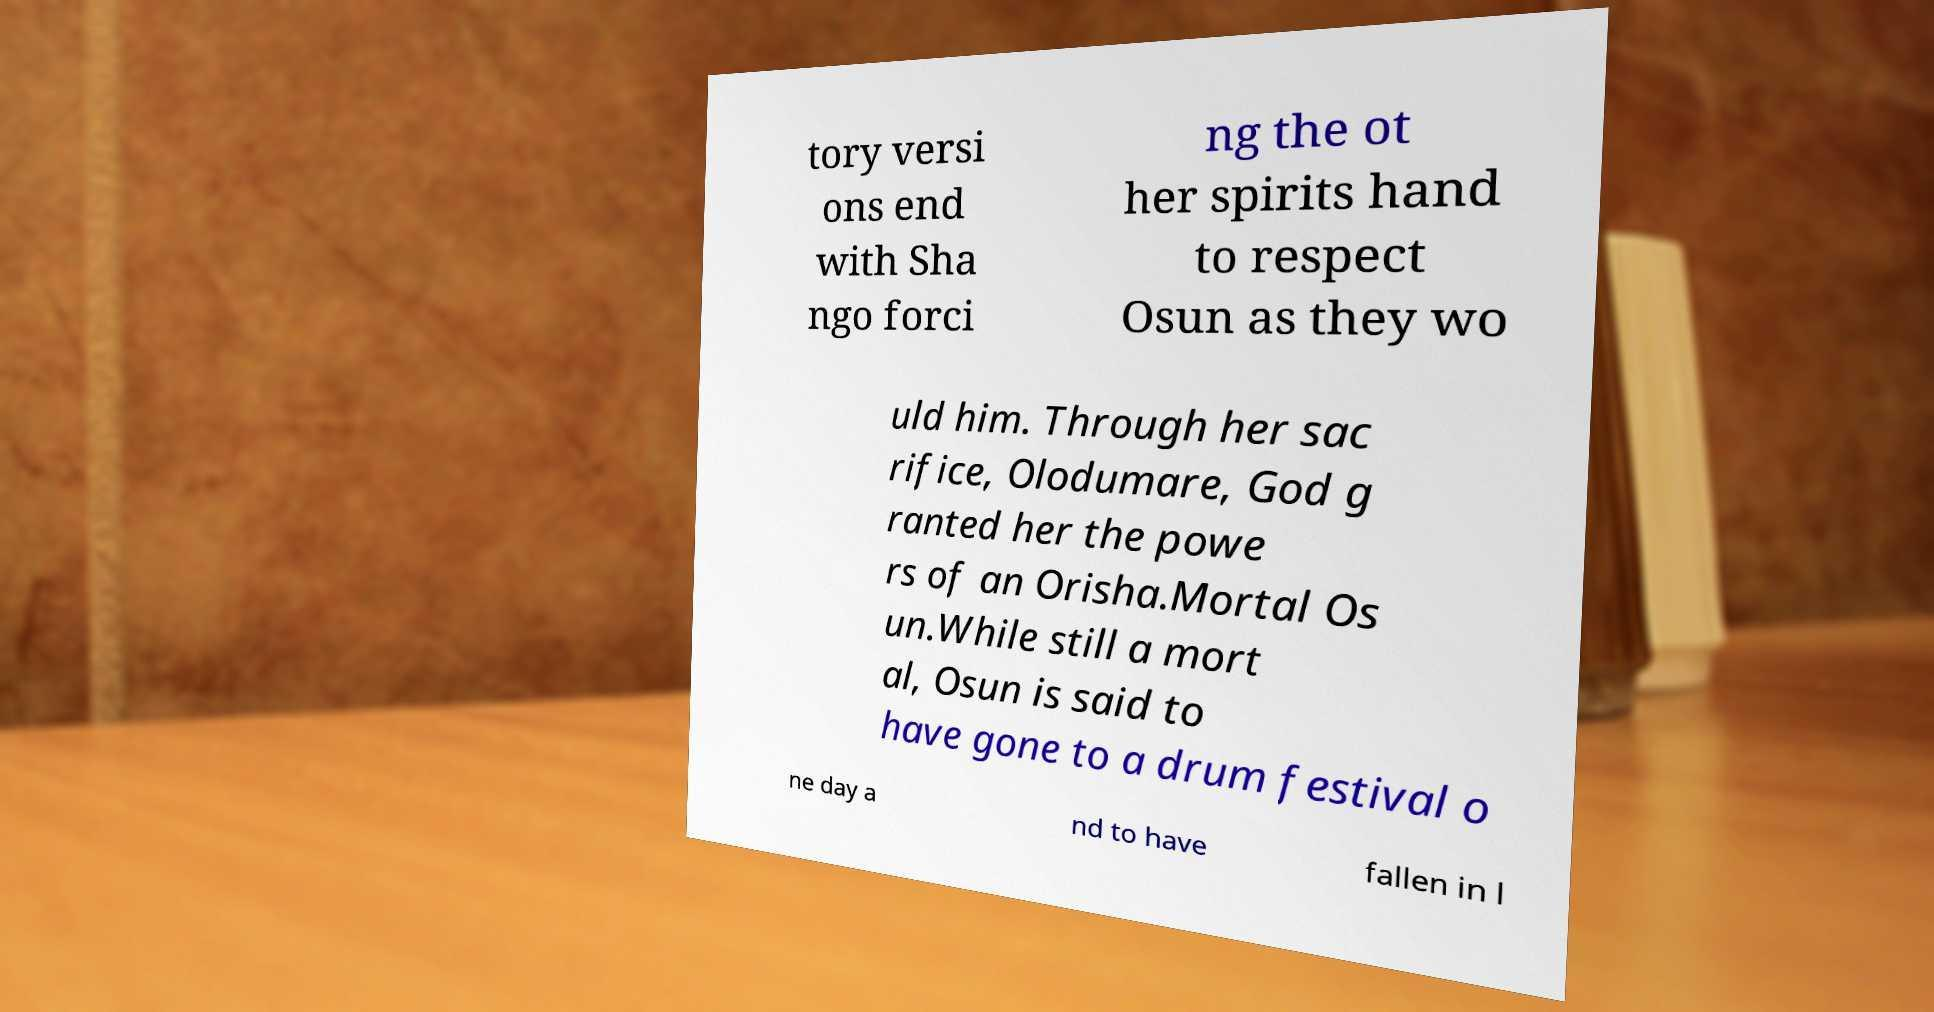I need the written content from this picture converted into text. Can you do that? tory versi ons end with Sha ngo forci ng the ot her spirits hand to respect Osun as they wo uld him. Through her sac rifice, Olodumare, God g ranted her the powe rs of an Orisha.Mortal Os un.While still a mort al, Osun is said to have gone to a drum festival o ne day a nd to have fallen in l 